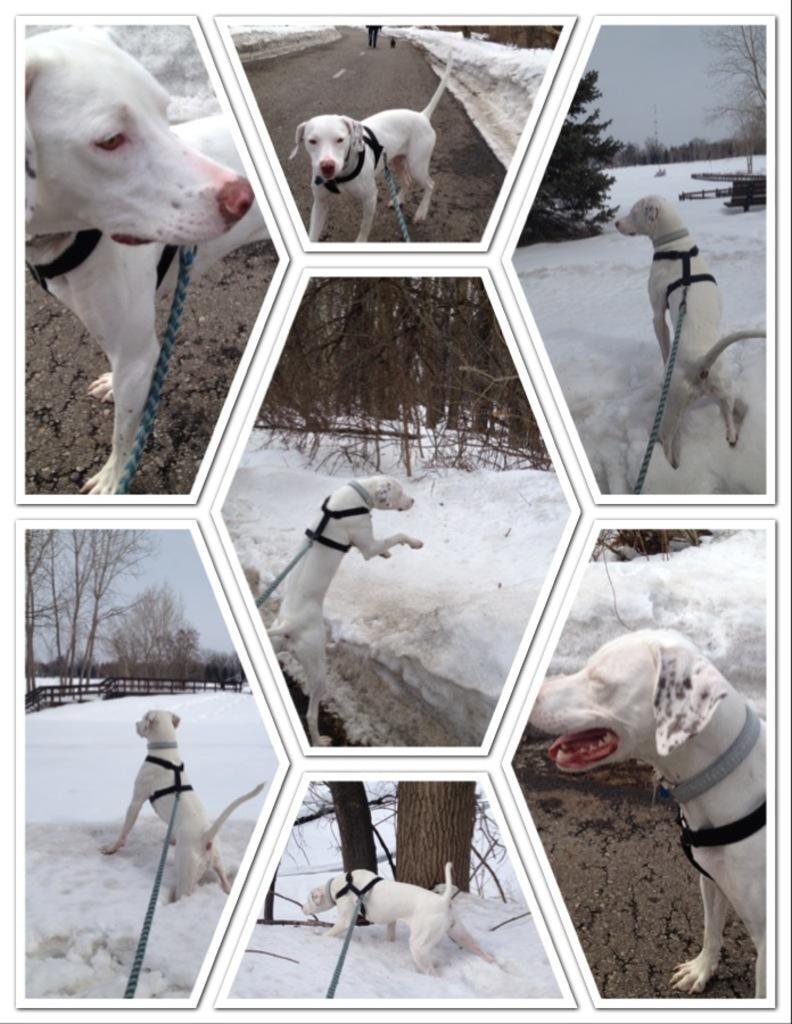Could you give a brief overview of what you see in this image? In this image we can see a collage of pictures in which we can see a dog on the ground, we can also see some trees, fence. In the background, we can see the sky. 